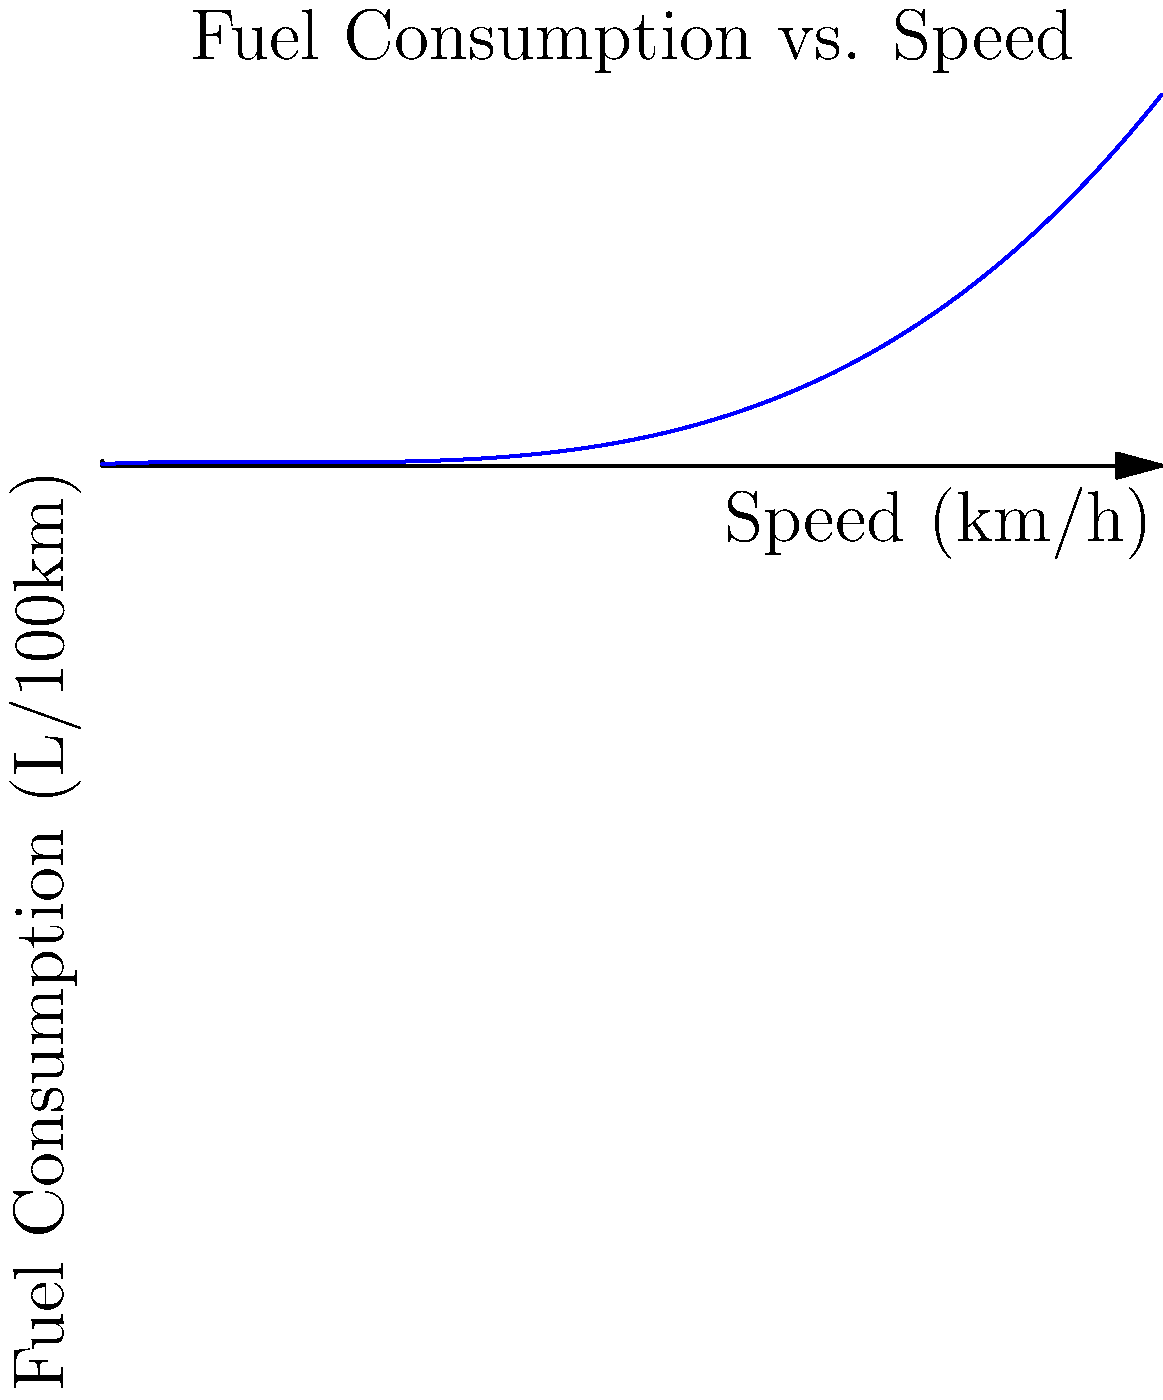As a young aspiring formula racing driver, you're analyzing fuel consumption data from your latest race. The graph shows the relationship between speed and fuel consumption, modeled by the polynomial function $f(x) = 0.0005x^3 - 0.05x^2 + 1.5x + 10$, where $x$ is the speed in km/h and $f(x)$ is the fuel consumption in L/100km. At what speed does the car achieve its minimum fuel consumption rate? To find the speed at which the car achieves its minimum fuel consumption rate, we need to follow these steps:

1) The minimum point of the function occurs where its derivative equals zero. So, we need to find $f'(x)$ and set it to zero.

2) $f'(x) = 0.0015x^2 - 0.1x + 1.5$

3) Set $f'(x) = 0$:
   $0.0015x^2 - 0.1x + 1.5 = 0$

4) This is a quadratic equation. We can solve it using the quadratic formula:
   $x = \frac{-b \pm \sqrt{b^2 - 4ac}}{2a}$

   Where $a = 0.0015$, $b = -0.1$, and $c = 1.5$

5) Plugging in these values:
   $x = \frac{0.1 \pm \sqrt{(-0.1)^2 - 4(0.0015)(1.5)}}{2(0.0015)}$

6) Simplifying:
   $x = \frac{0.1 \pm \sqrt{0.01 - 0.009}}{0.003} = \frac{0.1 \pm \sqrt{0.001}}{0.003} = \frac{0.1 \pm 0.0316}{0.003}$

7) This gives us two solutions:
   $x_1 = \frac{0.1 + 0.0316}{0.003} \approx 43.87$
   $x_2 = \frac{0.1 - 0.0316}{0.003} \approx 22.80$

8) Since we're looking for a minimum, and the coefficient of $x^3$ in the original function is positive (indicating the function goes up as $x$ increases), the larger value of $x$ corresponds to the maximum, and the smaller value corresponds to the minimum.

Therefore, the minimum fuel consumption occurs at approximately 22.80 km/h.
Answer: 22.80 km/h 